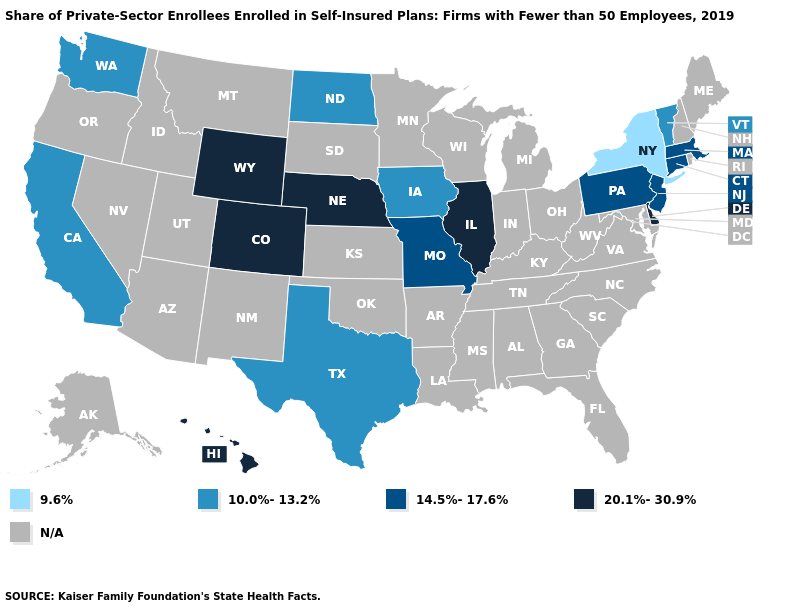Name the states that have a value in the range 9.6%?
Short answer required. New York. Name the states that have a value in the range 14.5%-17.6%?
Be succinct. Connecticut, Massachusetts, Missouri, New Jersey, Pennsylvania. How many symbols are there in the legend?
Write a very short answer. 5. Does the map have missing data?
Write a very short answer. Yes. Among the states that border Minnesota , which have the lowest value?
Concise answer only. Iowa, North Dakota. What is the value of Wyoming?
Short answer required. 20.1%-30.9%. What is the value of Arkansas?
Write a very short answer. N/A. Does Texas have the highest value in the South?
Answer briefly. No. What is the value of New Jersey?
Write a very short answer. 14.5%-17.6%. Among the states that border Tennessee , which have the highest value?
Short answer required. Missouri. Does Texas have the highest value in the USA?
Be succinct. No. Does Illinois have the highest value in the USA?
Keep it brief. Yes. Name the states that have a value in the range 10.0%-13.2%?
Concise answer only. California, Iowa, North Dakota, Texas, Vermont, Washington. 